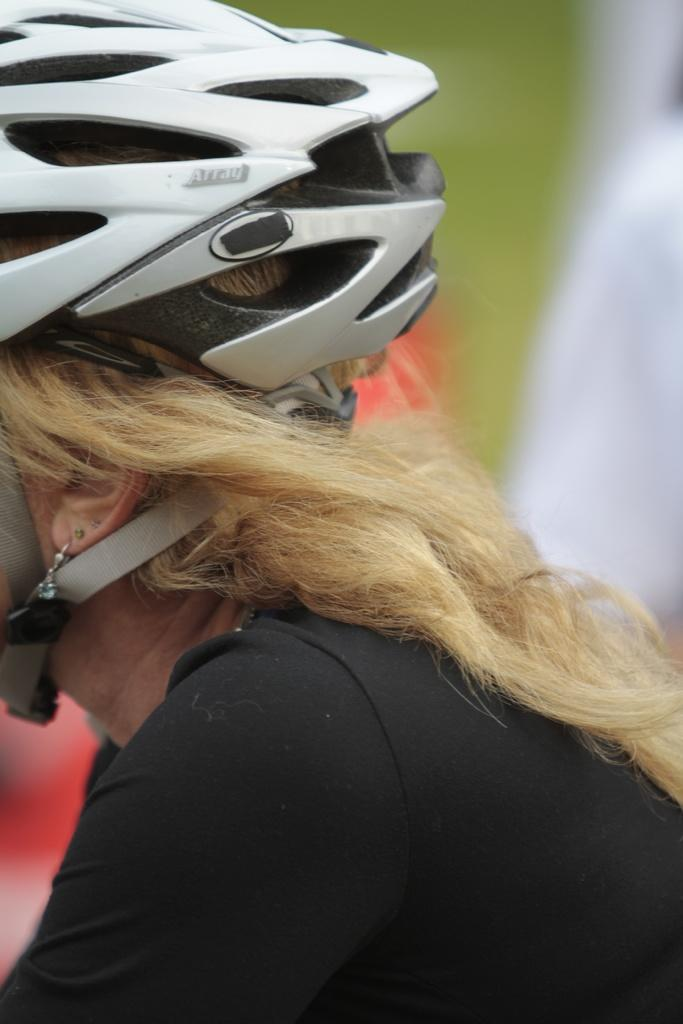What is the main subject of the image? The main subject of the image is a person's head. What is the person's head wearing? The person's head is wearing a helmet. What type of toy can be seen on the plate in the image? There is no plate or toy present in the image; it only features a person's head wearing a helmet. 